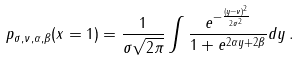<formula> <loc_0><loc_0><loc_500><loc_500>p _ { \sigma , \nu , \alpha , \beta } ( x = 1 ) = \frac { 1 } { \sigma \sqrt { 2 \pi } } \int \frac { e ^ { - \frac { ( y - \nu ) ^ { 2 } } { 2 \sigma ^ { 2 } } } } { 1 + e ^ { 2 \alpha y + 2 \beta } } d y \, .</formula> 